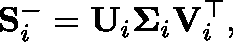Convert formula to latex. <formula><loc_0><loc_0><loc_500><loc_500>S _ { i } ^ { - } = U _ { i } \Sigma _ { i } V _ { i } ^ { \top } ,</formula> 